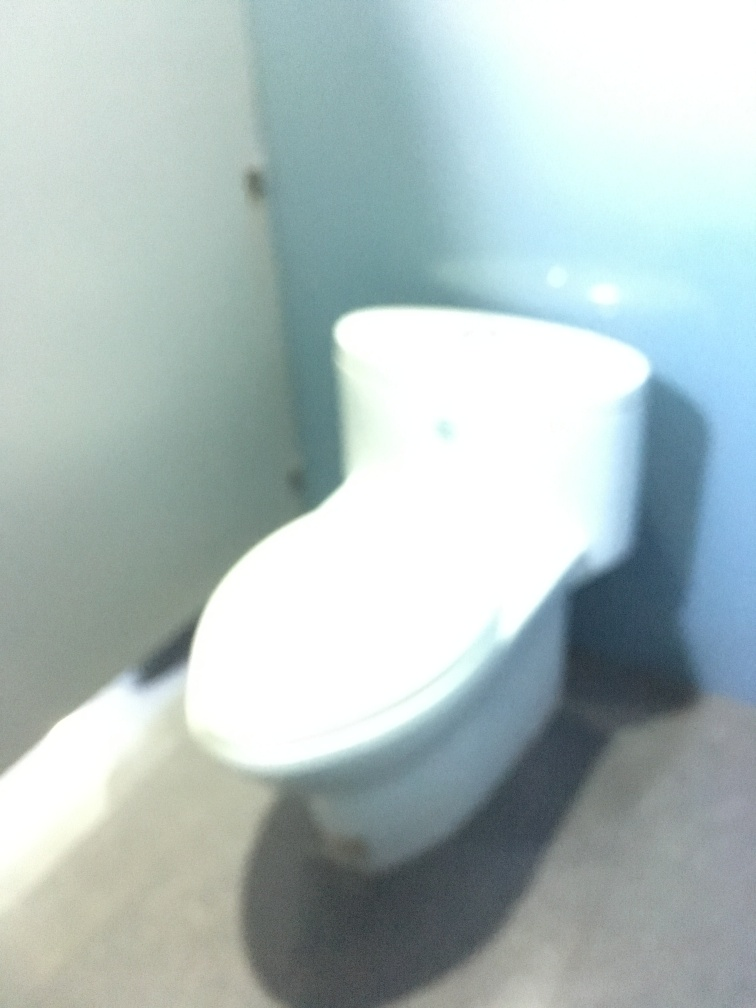Is the quality of the photo very poor? Yes, the quality of the photo is indeed very poor. The image suffers from significant blurriness and lack of focus, which makes it challenging to discern finer details. Proper focus and stable camera handling are essential for capturing a clear photograph, and it appears that these were not adequately managed at the time this was taken. 